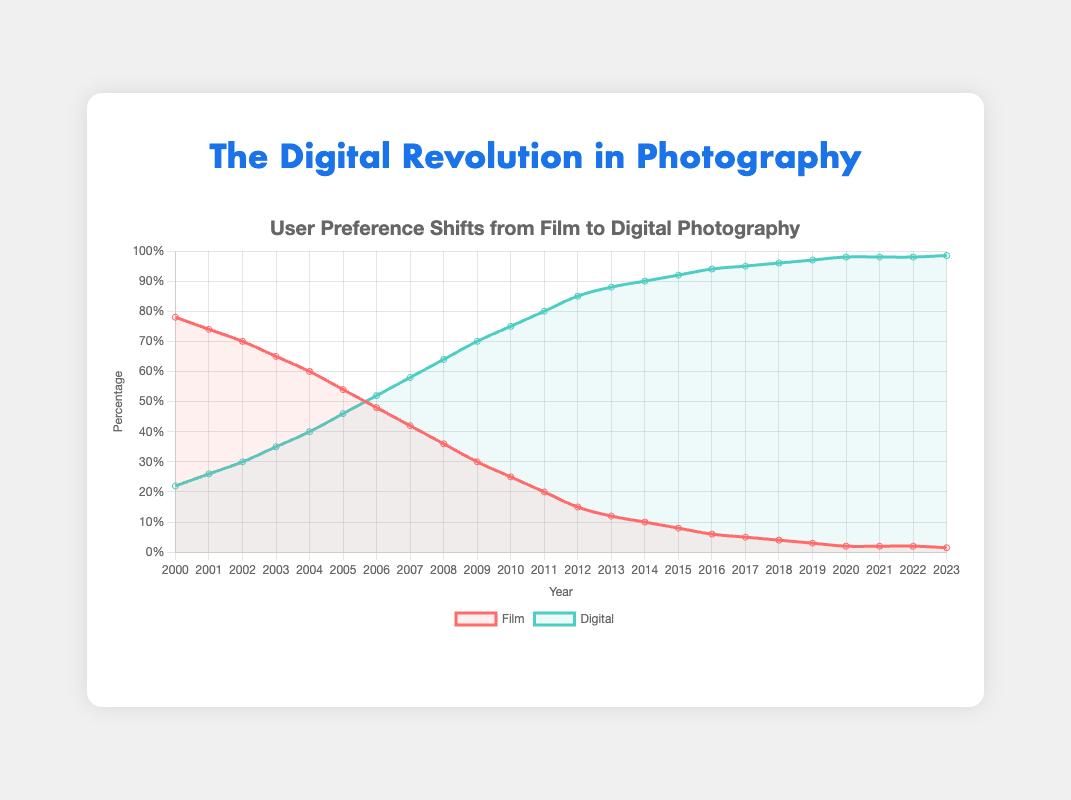What percentage of users preferred digital photography in 2005? Look at the data point for digital photography in 2005. The chart shows that in 2005, 46% of users preferred digital photography.
Answer: 46% What is the trend for film photography from 2000 to 2023? Observe the overall direction of the film photography data points from 2000 to 2023. The trend shows a consistent decline in the preference for film photography over the years.
Answer: Declining By how much did the percentage of digital photography preferences increase from 2000 to 2010? Subtract the digital percentage in 2000 from the digital percentage in 2010 (75% - 22%). The difference is the increase in digital photography preferences.
Answer: 53% Is there any year where the preference for film and digital photography was equal? Check if there is a year where the percentages for film and digital intersect. There is no such intersection point shown on the chart.
Answer: No In which year did digital photography preference exceed 50%? Identify the first year where the digital photography line crosses the 50% threshold on the chart. This occurs in 2006.
Answer: 2006 What is the approximate rate of decline in the film preference percentage from 2000 to 2005? Calculate the difference in film percentages for 2000 and 2005, then divide by the number of years (78% - 54%) / 5 years.
Answer: 4.8% per year Compare the percentage of users preferring film photography in 2010 and 2020. Read the film percentages for 2010 and 2020. In 2010, it's 25%, and in 2020, it's 2%. Digital was more preferred in both years.
Answer: Film preference dropped from 25% to 2% What is the average percentage increase in digital photography between 2000 and 2003? Calculate the yearly increases first: (26%-22%), (30%-26%), and (35%-30%), then find the average of these values (4% + 4% + 5%) / 3.
Answer: 4.33% Which percentage dropped faster over the years, film or digital? Compare the rate of change in both lines. The film percentage dropped faster, from 78% in 2000 to 1.5% in 2023, whereas digital increased from 22% to 98.5%.
Answer: Film When did the digital preference reach 90%? Look for the year when the digital preference reaches or exceeds 90%. This milestone is reached in 2014.
Answer: 2014 